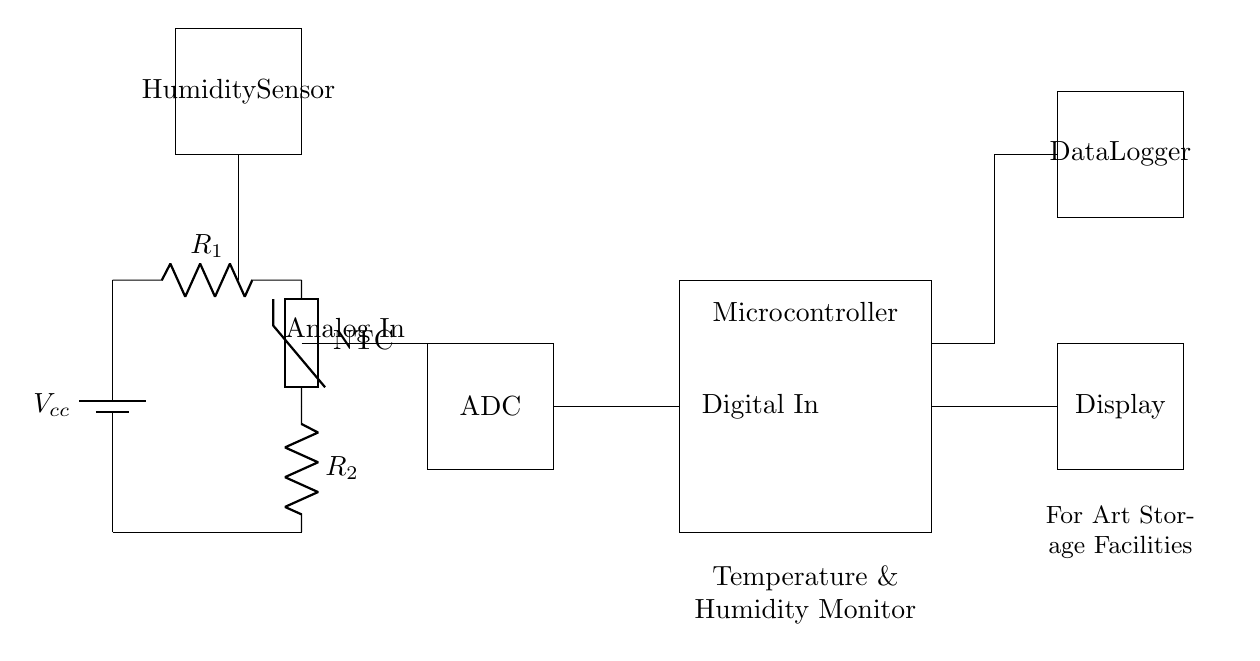What component is used for humidity measurement? The circuit includes a humidity sensor, which is clearly marked in the diagram as the component designated for humidity measurement.
Answer: Humidity Sensor What type of thermistor is shown in the diagram? The circuit diagram specifies the thermistor as an NTC (Negative Temperature Coefficient), indicating that its resistance decreases with an increase in temperature.
Answer: NTC How many resistors are present in the circuit? There are two resistors in the circuit that are labeled as R1 and R2.
Answer: Two What is the purpose of the ADC in the circuit? The ADC (Analog-to-Digital Converter) is used to convert the analog signals from the sensors into digital signals that can be processed by the microcontroller.
Answer: Convert analog to digital Which component is responsible for displaying the temperature and humidity? The display component, marked in the diagram, is dedicated to showing the temperature and humidity readings processed by the microcontroller.
Answer: Display Explain the function of the microcontroller in this circuit. The microcontroller processes the digital signals from the ADC and controls the display and data logger. It acts as the main control unit, coordinating the functionality of the entire monitoring system.
Answer: Main control unit How do the analog and digital parts of the circuit interact? The analog part, including the thermistor and humidity sensor, measures environmental conditions and sends this information to the ADC. The ADC then converts the analog signals to digital form for the microcontroller to process, allowing the system to monitor both temperature and humidity effectively.
Answer: They interact via conversion and processing 